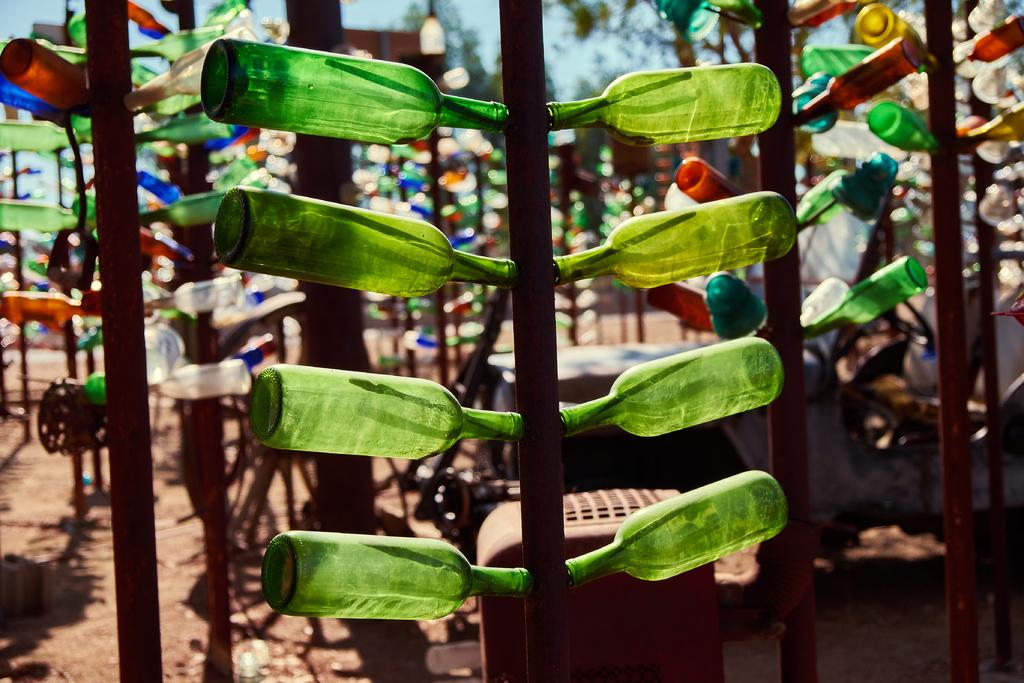What is the main object in the image? There is a brown color pole in the image. What is attached to the pole? Bottles are attached to the pole on both sides. What can be seen in the background of the image? There is a sky, lights, and trees visible in the background of the image. How many partners are visible in the image? There are no partners present in the image; it features a brown color pole with bottles attached to it and a background with sky, lights, and trees. 